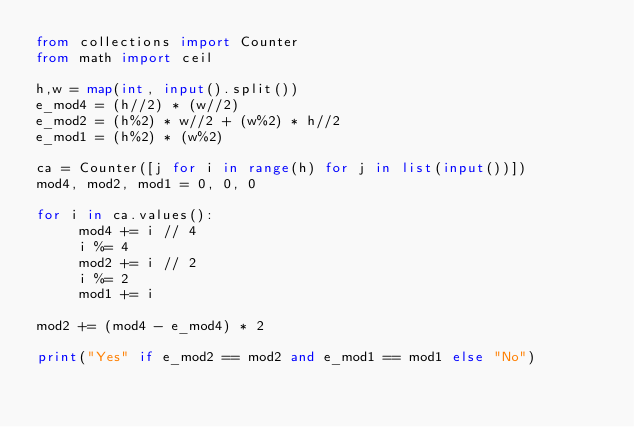<code> <loc_0><loc_0><loc_500><loc_500><_Python_>from collections import Counter
from math import ceil

h,w = map(int, input().split())
e_mod4 = (h//2) * (w//2)
e_mod2 = (h%2) * w//2 + (w%2) * h//2
e_mod1 = (h%2) * (w%2)

ca = Counter([j for i in range(h) for j in list(input())])
mod4, mod2, mod1 = 0, 0, 0

for i in ca.values():
     mod4 += i // 4
     i %= 4
     mod2 += i // 2
     i %= 2
     mod1 += i

mod2 += (mod4 - e_mod4) * 2

print("Yes" if e_mod2 == mod2 and e_mod1 == mod1 else "No")</code> 